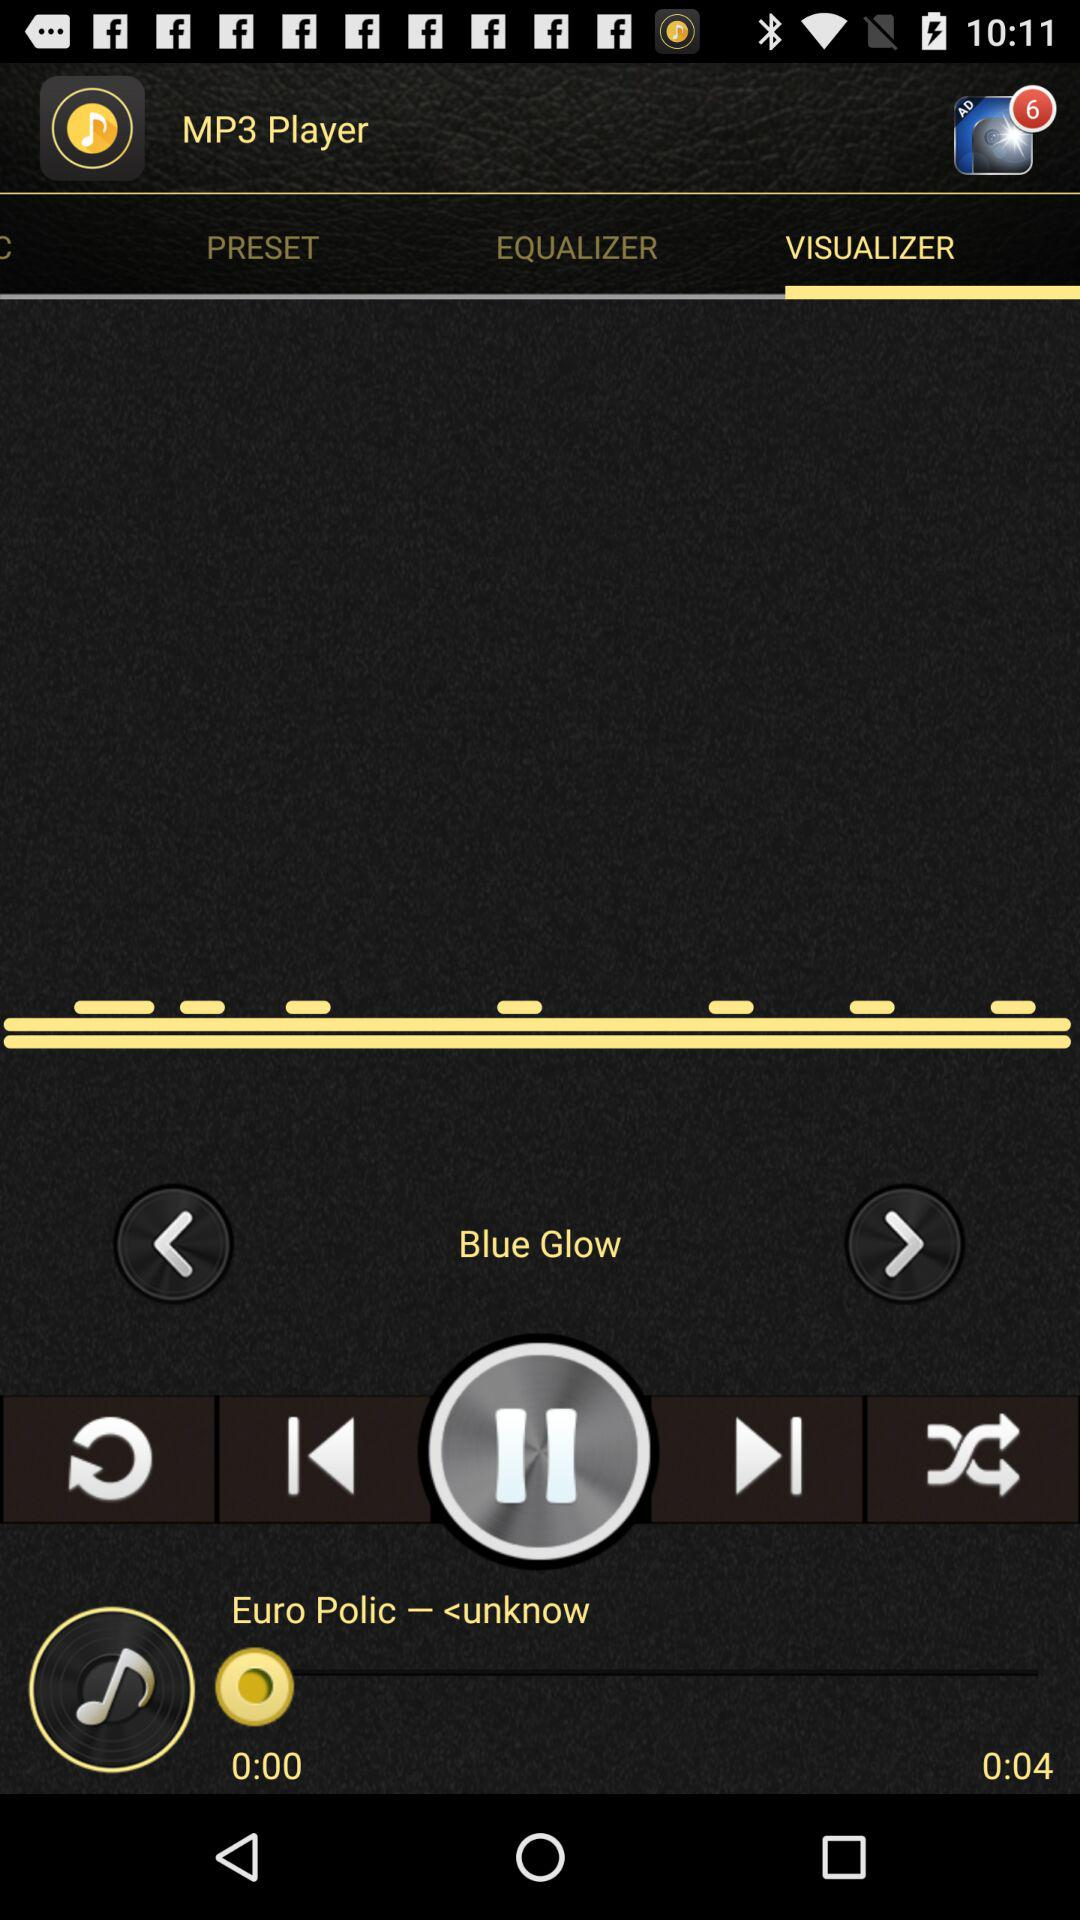Which song is currently playing? The song currently playing is "Euro Polic". 